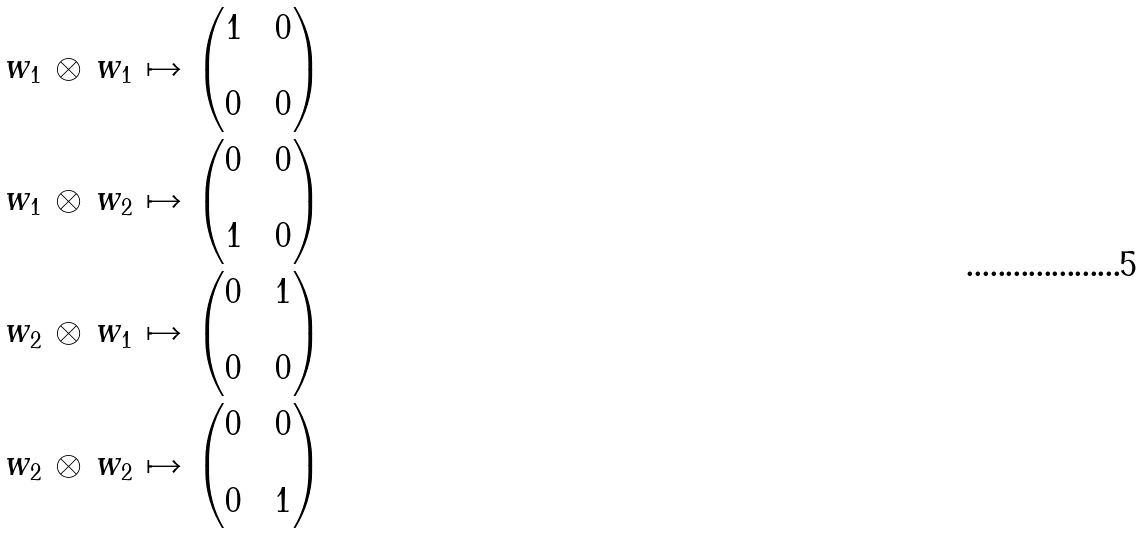Convert formula to latex. <formula><loc_0><loc_0><loc_500><loc_500>w _ { 1 } \, \otimes \, w _ { 1 } \, \mapsto \, & \begin{pmatrix} 1 & & 0 \\ \\ 0 & & 0 \end{pmatrix} \\ w _ { 1 } \, \otimes \, w _ { 2 } \, \mapsto \, & \begin{pmatrix} 0 & & 0 \\ \\ 1 & & 0 \end{pmatrix} \\ w _ { 2 } \, \otimes \, w _ { 1 } \, \mapsto \, & \begin{pmatrix} 0 & & 1 \\ \\ 0 & & 0 \end{pmatrix} \\ w _ { 2 } \, \otimes \, w _ { 2 } \, \mapsto \, & \begin{pmatrix} 0 & & 0 \\ \\ 0 & & 1 \end{pmatrix}</formula> 